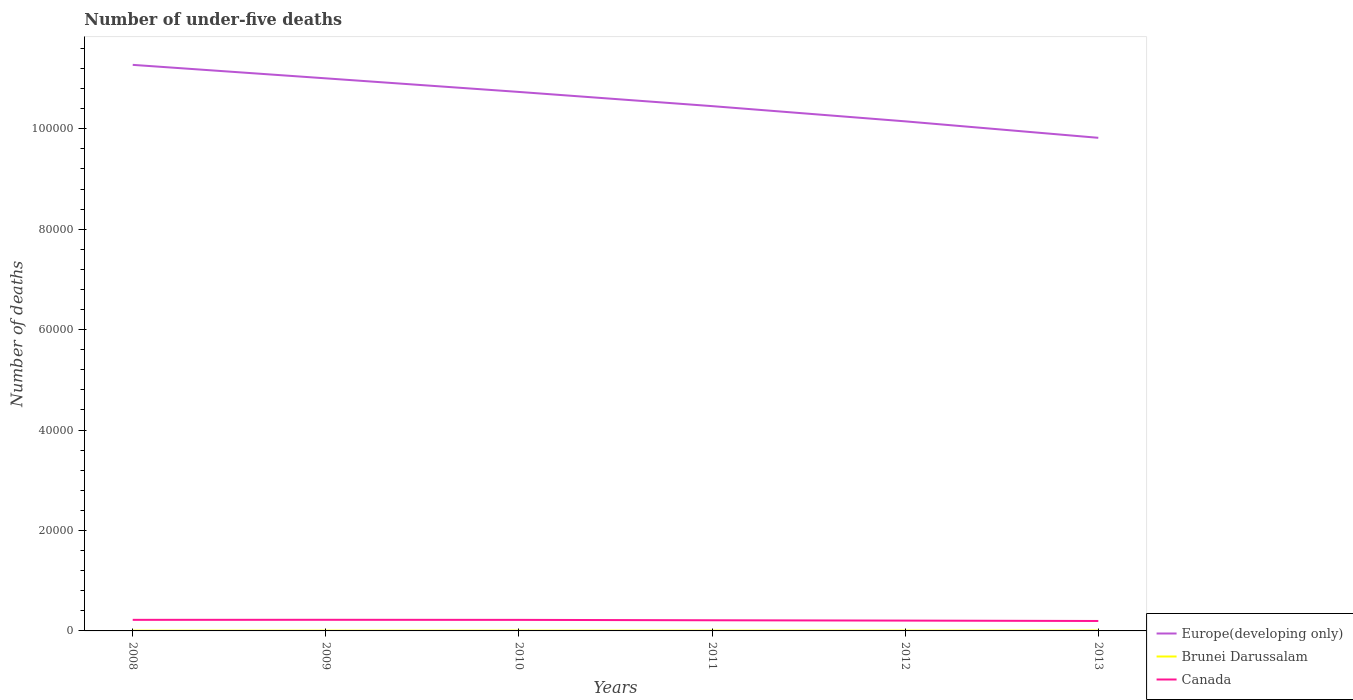How many different coloured lines are there?
Offer a very short reply. 3. Does the line corresponding to Europe(developing only) intersect with the line corresponding to Canada?
Provide a short and direct response. No. Across all years, what is the maximum number of under-five deaths in Canada?
Provide a short and direct response. 1978. What is the total number of under-five deaths in Brunei Darussalam in the graph?
Provide a short and direct response. -14. What is the difference between the highest and the second highest number of under-five deaths in Canada?
Your answer should be very brief. 239. What is the difference between the highest and the lowest number of under-five deaths in Canada?
Your answer should be compact. 3. Does the graph contain grids?
Keep it short and to the point. No. Where does the legend appear in the graph?
Provide a short and direct response. Bottom right. How are the legend labels stacked?
Your response must be concise. Vertical. What is the title of the graph?
Offer a terse response. Number of under-five deaths. What is the label or title of the Y-axis?
Offer a very short reply. Number of deaths. What is the Number of deaths in Europe(developing only) in 2008?
Your response must be concise. 1.13e+05. What is the Number of deaths in Brunei Darussalam in 2008?
Provide a short and direct response. 53. What is the Number of deaths of Canada in 2008?
Provide a succinct answer. 2206. What is the Number of deaths of Europe(developing only) in 2009?
Provide a succinct answer. 1.10e+05. What is the Number of deaths in Brunei Darussalam in 2009?
Your answer should be very brief. 53. What is the Number of deaths in Canada in 2009?
Keep it short and to the point. 2217. What is the Number of deaths in Europe(developing only) in 2010?
Ensure brevity in your answer.  1.07e+05. What is the Number of deaths of Canada in 2010?
Ensure brevity in your answer.  2201. What is the Number of deaths of Europe(developing only) in 2011?
Offer a very short reply. 1.05e+05. What is the Number of deaths in Canada in 2011?
Provide a short and direct response. 2121. What is the Number of deaths of Europe(developing only) in 2012?
Keep it short and to the point. 1.01e+05. What is the Number of deaths of Canada in 2012?
Ensure brevity in your answer.  2056. What is the Number of deaths in Europe(developing only) in 2013?
Your answer should be compact. 9.82e+04. What is the Number of deaths in Brunei Darussalam in 2013?
Offer a very short reply. 69. What is the Number of deaths in Canada in 2013?
Your response must be concise. 1978. Across all years, what is the maximum Number of deaths in Europe(developing only)?
Give a very brief answer. 1.13e+05. Across all years, what is the maximum Number of deaths in Brunei Darussalam?
Keep it short and to the point. 69. Across all years, what is the maximum Number of deaths of Canada?
Offer a terse response. 2217. Across all years, what is the minimum Number of deaths of Europe(developing only)?
Provide a short and direct response. 9.82e+04. Across all years, what is the minimum Number of deaths of Brunei Darussalam?
Offer a terse response. 53. Across all years, what is the minimum Number of deaths in Canada?
Provide a short and direct response. 1978. What is the total Number of deaths in Europe(developing only) in the graph?
Ensure brevity in your answer.  6.34e+05. What is the total Number of deaths of Brunei Darussalam in the graph?
Offer a very short reply. 351. What is the total Number of deaths of Canada in the graph?
Offer a terse response. 1.28e+04. What is the difference between the Number of deaths in Europe(developing only) in 2008 and that in 2009?
Offer a very short reply. 2685. What is the difference between the Number of deaths of Canada in 2008 and that in 2009?
Make the answer very short. -11. What is the difference between the Number of deaths in Europe(developing only) in 2008 and that in 2010?
Make the answer very short. 5391. What is the difference between the Number of deaths in Brunei Darussalam in 2008 and that in 2010?
Provide a short and direct response. -2. What is the difference between the Number of deaths in Europe(developing only) in 2008 and that in 2011?
Give a very brief answer. 8218. What is the difference between the Number of deaths of Brunei Darussalam in 2008 and that in 2011?
Provide a succinct answer. -5. What is the difference between the Number of deaths of Europe(developing only) in 2008 and that in 2012?
Provide a succinct answer. 1.12e+04. What is the difference between the Number of deaths of Canada in 2008 and that in 2012?
Your answer should be very brief. 150. What is the difference between the Number of deaths of Europe(developing only) in 2008 and that in 2013?
Your response must be concise. 1.45e+04. What is the difference between the Number of deaths in Canada in 2008 and that in 2013?
Offer a terse response. 228. What is the difference between the Number of deaths in Europe(developing only) in 2009 and that in 2010?
Your response must be concise. 2706. What is the difference between the Number of deaths in Brunei Darussalam in 2009 and that in 2010?
Your answer should be very brief. -2. What is the difference between the Number of deaths of Europe(developing only) in 2009 and that in 2011?
Make the answer very short. 5533. What is the difference between the Number of deaths of Brunei Darussalam in 2009 and that in 2011?
Keep it short and to the point. -5. What is the difference between the Number of deaths of Canada in 2009 and that in 2011?
Provide a succinct answer. 96. What is the difference between the Number of deaths in Europe(developing only) in 2009 and that in 2012?
Give a very brief answer. 8563. What is the difference between the Number of deaths in Canada in 2009 and that in 2012?
Your answer should be compact. 161. What is the difference between the Number of deaths in Europe(developing only) in 2009 and that in 2013?
Ensure brevity in your answer.  1.18e+04. What is the difference between the Number of deaths of Canada in 2009 and that in 2013?
Make the answer very short. 239. What is the difference between the Number of deaths in Europe(developing only) in 2010 and that in 2011?
Offer a terse response. 2827. What is the difference between the Number of deaths in Canada in 2010 and that in 2011?
Give a very brief answer. 80. What is the difference between the Number of deaths of Europe(developing only) in 2010 and that in 2012?
Provide a short and direct response. 5857. What is the difference between the Number of deaths of Canada in 2010 and that in 2012?
Your answer should be compact. 145. What is the difference between the Number of deaths in Europe(developing only) in 2010 and that in 2013?
Your answer should be compact. 9137. What is the difference between the Number of deaths in Canada in 2010 and that in 2013?
Provide a succinct answer. 223. What is the difference between the Number of deaths in Europe(developing only) in 2011 and that in 2012?
Ensure brevity in your answer.  3030. What is the difference between the Number of deaths in Brunei Darussalam in 2011 and that in 2012?
Ensure brevity in your answer.  -5. What is the difference between the Number of deaths of Europe(developing only) in 2011 and that in 2013?
Give a very brief answer. 6310. What is the difference between the Number of deaths of Canada in 2011 and that in 2013?
Provide a short and direct response. 143. What is the difference between the Number of deaths of Europe(developing only) in 2012 and that in 2013?
Make the answer very short. 3280. What is the difference between the Number of deaths in Canada in 2012 and that in 2013?
Your response must be concise. 78. What is the difference between the Number of deaths of Europe(developing only) in 2008 and the Number of deaths of Brunei Darussalam in 2009?
Your answer should be compact. 1.13e+05. What is the difference between the Number of deaths in Europe(developing only) in 2008 and the Number of deaths in Canada in 2009?
Your answer should be compact. 1.11e+05. What is the difference between the Number of deaths in Brunei Darussalam in 2008 and the Number of deaths in Canada in 2009?
Ensure brevity in your answer.  -2164. What is the difference between the Number of deaths of Europe(developing only) in 2008 and the Number of deaths of Brunei Darussalam in 2010?
Provide a short and direct response. 1.13e+05. What is the difference between the Number of deaths in Europe(developing only) in 2008 and the Number of deaths in Canada in 2010?
Make the answer very short. 1.11e+05. What is the difference between the Number of deaths in Brunei Darussalam in 2008 and the Number of deaths in Canada in 2010?
Your answer should be very brief. -2148. What is the difference between the Number of deaths of Europe(developing only) in 2008 and the Number of deaths of Brunei Darussalam in 2011?
Keep it short and to the point. 1.13e+05. What is the difference between the Number of deaths in Europe(developing only) in 2008 and the Number of deaths in Canada in 2011?
Offer a terse response. 1.11e+05. What is the difference between the Number of deaths of Brunei Darussalam in 2008 and the Number of deaths of Canada in 2011?
Make the answer very short. -2068. What is the difference between the Number of deaths in Europe(developing only) in 2008 and the Number of deaths in Brunei Darussalam in 2012?
Keep it short and to the point. 1.13e+05. What is the difference between the Number of deaths in Europe(developing only) in 2008 and the Number of deaths in Canada in 2012?
Your answer should be very brief. 1.11e+05. What is the difference between the Number of deaths of Brunei Darussalam in 2008 and the Number of deaths of Canada in 2012?
Ensure brevity in your answer.  -2003. What is the difference between the Number of deaths of Europe(developing only) in 2008 and the Number of deaths of Brunei Darussalam in 2013?
Keep it short and to the point. 1.13e+05. What is the difference between the Number of deaths in Europe(developing only) in 2008 and the Number of deaths in Canada in 2013?
Provide a succinct answer. 1.11e+05. What is the difference between the Number of deaths in Brunei Darussalam in 2008 and the Number of deaths in Canada in 2013?
Your response must be concise. -1925. What is the difference between the Number of deaths of Europe(developing only) in 2009 and the Number of deaths of Brunei Darussalam in 2010?
Make the answer very short. 1.10e+05. What is the difference between the Number of deaths of Europe(developing only) in 2009 and the Number of deaths of Canada in 2010?
Ensure brevity in your answer.  1.08e+05. What is the difference between the Number of deaths in Brunei Darussalam in 2009 and the Number of deaths in Canada in 2010?
Provide a short and direct response. -2148. What is the difference between the Number of deaths in Europe(developing only) in 2009 and the Number of deaths in Brunei Darussalam in 2011?
Provide a short and direct response. 1.10e+05. What is the difference between the Number of deaths of Europe(developing only) in 2009 and the Number of deaths of Canada in 2011?
Provide a succinct answer. 1.08e+05. What is the difference between the Number of deaths of Brunei Darussalam in 2009 and the Number of deaths of Canada in 2011?
Your answer should be compact. -2068. What is the difference between the Number of deaths in Europe(developing only) in 2009 and the Number of deaths in Brunei Darussalam in 2012?
Your answer should be compact. 1.10e+05. What is the difference between the Number of deaths in Europe(developing only) in 2009 and the Number of deaths in Canada in 2012?
Your response must be concise. 1.08e+05. What is the difference between the Number of deaths of Brunei Darussalam in 2009 and the Number of deaths of Canada in 2012?
Offer a terse response. -2003. What is the difference between the Number of deaths in Europe(developing only) in 2009 and the Number of deaths in Brunei Darussalam in 2013?
Ensure brevity in your answer.  1.10e+05. What is the difference between the Number of deaths of Europe(developing only) in 2009 and the Number of deaths of Canada in 2013?
Offer a terse response. 1.08e+05. What is the difference between the Number of deaths in Brunei Darussalam in 2009 and the Number of deaths in Canada in 2013?
Your response must be concise. -1925. What is the difference between the Number of deaths of Europe(developing only) in 2010 and the Number of deaths of Brunei Darussalam in 2011?
Keep it short and to the point. 1.07e+05. What is the difference between the Number of deaths of Europe(developing only) in 2010 and the Number of deaths of Canada in 2011?
Provide a succinct answer. 1.05e+05. What is the difference between the Number of deaths of Brunei Darussalam in 2010 and the Number of deaths of Canada in 2011?
Offer a terse response. -2066. What is the difference between the Number of deaths in Europe(developing only) in 2010 and the Number of deaths in Brunei Darussalam in 2012?
Provide a short and direct response. 1.07e+05. What is the difference between the Number of deaths of Europe(developing only) in 2010 and the Number of deaths of Canada in 2012?
Keep it short and to the point. 1.05e+05. What is the difference between the Number of deaths of Brunei Darussalam in 2010 and the Number of deaths of Canada in 2012?
Provide a short and direct response. -2001. What is the difference between the Number of deaths of Europe(developing only) in 2010 and the Number of deaths of Brunei Darussalam in 2013?
Your answer should be compact. 1.07e+05. What is the difference between the Number of deaths in Europe(developing only) in 2010 and the Number of deaths in Canada in 2013?
Keep it short and to the point. 1.05e+05. What is the difference between the Number of deaths in Brunei Darussalam in 2010 and the Number of deaths in Canada in 2013?
Offer a terse response. -1923. What is the difference between the Number of deaths in Europe(developing only) in 2011 and the Number of deaths in Brunei Darussalam in 2012?
Ensure brevity in your answer.  1.04e+05. What is the difference between the Number of deaths in Europe(developing only) in 2011 and the Number of deaths in Canada in 2012?
Provide a succinct answer. 1.02e+05. What is the difference between the Number of deaths in Brunei Darussalam in 2011 and the Number of deaths in Canada in 2012?
Make the answer very short. -1998. What is the difference between the Number of deaths in Europe(developing only) in 2011 and the Number of deaths in Brunei Darussalam in 2013?
Your answer should be compact. 1.04e+05. What is the difference between the Number of deaths of Europe(developing only) in 2011 and the Number of deaths of Canada in 2013?
Make the answer very short. 1.03e+05. What is the difference between the Number of deaths of Brunei Darussalam in 2011 and the Number of deaths of Canada in 2013?
Your answer should be compact. -1920. What is the difference between the Number of deaths in Europe(developing only) in 2012 and the Number of deaths in Brunei Darussalam in 2013?
Your response must be concise. 1.01e+05. What is the difference between the Number of deaths of Europe(developing only) in 2012 and the Number of deaths of Canada in 2013?
Provide a short and direct response. 9.95e+04. What is the difference between the Number of deaths of Brunei Darussalam in 2012 and the Number of deaths of Canada in 2013?
Your answer should be very brief. -1915. What is the average Number of deaths of Europe(developing only) per year?
Keep it short and to the point. 1.06e+05. What is the average Number of deaths in Brunei Darussalam per year?
Ensure brevity in your answer.  58.5. What is the average Number of deaths in Canada per year?
Give a very brief answer. 2129.83. In the year 2008, what is the difference between the Number of deaths of Europe(developing only) and Number of deaths of Brunei Darussalam?
Your answer should be very brief. 1.13e+05. In the year 2008, what is the difference between the Number of deaths of Europe(developing only) and Number of deaths of Canada?
Provide a succinct answer. 1.11e+05. In the year 2008, what is the difference between the Number of deaths of Brunei Darussalam and Number of deaths of Canada?
Provide a short and direct response. -2153. In the year 2009, what is the difference between the Number of deaths in Europe(developing only) and Number of deaths in Brunei Darussalam?
Provide a succinct answer. 1.10e+05. In the year 2009, what is the difference between the Number of deaths of Europe(developing only) and Number of deaths of Canada?
Give a very brief answer. 1.08e+05. In the year 2009, what is the difference between the Number of deaths of Brunei Darussalam and Number of deaths of Canada?
Your answer should be compact. -2164. In the year 2010, what is the difference between the Number of deaths of Europe(developing only) and Number of deaths of Brunei Darussalam?
Provide a short and direct response. 1.07e+05. In the year 2010, what is the difference between the Number of deaths in Europe(developing only) and Number of deaths in Canada?
Your answer should be very brief. 1.05e+05. In the year 2010, what is the difference between the Number of deaths of Brunei Darussalam and Number of deaths of Canada?
Keep it short and to the point. -2146. In the year 2011, what is the difference between the Number of deaths of Europe(developing only) and Number of deaths of Brunei Darussalam?
Your answer should be very brief. 1.04e+05. In the year 2011, what is the difference between the Number of deaths of Europe(developing only) and Number of deaths of Canada?
Make the answer very short. 1.02e+05. In the year 2011, what is the difference between the Number of deaths of Brunei Darussalam and Number of deaths of Canada?
Make the answer very short. -2063. In the year 2012, what is the difference between the Number of deaths of Europe(developing only) and Number of deaths of Brunei Darussalam?
Offer a very short reply. 1.01e+05. In the year 2012, what is the difference between the Number of deaths in Europe(developing only) and Number of deaths in Canada?
Provide a succinct answer. 9.94e+04. In the year 2012, what is the difference between the Number of deaths of Brunei Darussalam and Number of deaths of Canada?
Provide a short and direct response. -1993. In the year 2013, what is the difference between the Number of deaths of Europe(developing only) and Number of deaths of Brunei Darussalam?
Your answer should be very brief. 9.81e+04. In the year 2013, what is the difference between the Number of deaths of Europe(developing only) and Number of deaths of Canada?
Offer a terse response. 9.62e+04. In the year 2013, what is the difference between the Number of deaths in Brunei Darussalam and Number of deaths in Canada?
Offer a very short reply. -1909. What is the ratio of the Number of deaths in Europe(developing only) in 2008 to that in 2009?
Keep it short and to the point. 1.02. What is the ratio of the Number of deaths of Canada in 2008 to that in 2009?
Ensure brevity in your answer.  0.99. What is the ratio of the Number of deaths of Europe(developing only) in 2008 to that in 2010?
Give a very brief answer. 1.05. What is the ratio of the Number of deaths in Brunei Darussalam in 2008 to that in 2010?
Offer a very short reply. 0.96. What is the ratio of the Number of deaths in Canada in 2008 to that in 2010?
Your answer should be compact. 1. What is the ratio of the Number of deaths of Europe(developing only) in 2008 to that in 2011?
Provide a succinct answer. 1.08. What is the ratio of the Number of deaths in Brunei Darussalam in 2008 to that in 2011?
Keep it short and to the point. 0.91. What is the ratio of the Number of deaths of Canada in 2008 to that in 2011?
Keep it short and to the point. 1.04. What is the ratio of the Number of deaths of Europe(developing only) in 2008 to that in 2012?
Offer a very short reply. 1.11. What is the ratio of the Number of deaths of Brunei Darussalam in 2008 to that in 2012?
Provide a short and direct response. 0.84. What is the ratio of the Number of deaths of Canada in 2008 to that in 2012?
Your answer should be very brief. 1.07. What is the ratio of the Number of deaths in Europe(developing only) in 2008 to that in 2013?
Your answer should be very brief. 1.15. What is the ratio of the Number of deaths in Brunei Darussalam in 2008 to that in 2013?
Provide a short and direct response. 0.77. What is the ratio of the Number of deaths of Canada in 2008 to that in 2013?
Provide a succinct answer. 1.12. What is the ratio of the Number of deaths of Europe(developing only) in 2009 to that in 2010?
Offer a terse response. 1.03. What is the ratio of the Number of deaths in Brunei Darussalam in 2009 to that in 2010?
Keep it short and to the point. 0.96. What is the ratio of the Number of deaths in Canada in 2009 to that in 2010?
Provide a short and direct response. 1.01. What is the ratio of the Number of deaths in Europe(developing only) in 2009 to that in 2011?
Make the answer very short. 1.05. What is the ratio of the Number of deaths of Brunei Darussalam in 2009 to that in 2011?
Keep it short and to the point. 0.91. What is the ratio of the Number of deaths in Canada in 2009 to that in 2011?
Offer a terse response. 1.05. What is the ratio of the Number of deaths in Europe(developing only) in 2009 to that in 2012?
Your response must be concise. 1.08. What is the ratio of the Number of deaths in Brunei Darussalam in 2009 to that in 2012?
Your response must be concise. 0.84. What is the ratio of the Number of deaths in Canada in 2009 to that in 2012?
Provide a succinct answer. 1.08. What is the ratio of the Number of deaths of Europe(developing only) in 2009 to that in 2013?
Your answer should be very brief. 1.12. What is the ratio of the Number of deaths of Brunei Darussalam in 2009 to that in 2013?
Your answer should be compact. 0.77. What is the ratio of the Number of deaths of Canada in 2009 to that in 2013?
Your answer should be very brief. 1.12. What is the ratio of the Number of deaths of Europe(developing only) in 2010 to that in 2011?
Your answer should be compact. 1.03. What is the ratio of the Number of deaths of Brunei Darussalam in 2010 to that in 2011?
Your answer should be compact. 0.95. What is the ratio of the Number of deaths of Canada in 2010 to that in 2011?
Your answer should be compact. 1.04. What is the ratio of the Number of deaths of Europe(developing only) in 2010 to that in 2012?
Provide a succinct answer. 1.06. What is the ratio of the Number of deaths of Brunei Darussalam in 2010 to that in 2012?
Provide a succinct answer. 0.87. What is the ratio of the Number of deaths in Canada in 2010 to that in 2012?
Offer a terse response. 1.07. What is the ratio of the Number of deaths of Europe(developing only) in 2010 to that in 2013?
Give a very brief answer. 1.09. What is the ratio of the Number of deaths in Brunei Darussalam in 2010 to that in 2013?
Your answer should be very brief. 0.8. What is the ratio of the Number of deaths in Canada in 2010 to that in 2013?
Ensure brevity in your answer.  1.11. What is the ratio of the Number of deaths of Europe(developing only) in 2011 to that in 2012?
Keep it short and to the point. 1.03. What is the ratio of the Number of deaths in Brunei Darussalam in 2011 to that in 2012?
Provide a succinct answer. 0.92. What is the ratio of the Number of deaths of Canada in 2011 to that in 2012?
Your answer should be compact. 1.03. What is the ratio of the Number of deaths in Europe(developing only) in 2011 to that in 2013?
Give a very brief answer. 1.06. What is the ratio of the Number of deaths in Brunei Darussalam in 2011 to that in 2013?
Provide a short and direct response. 0.84. What is the ratio of the Number of deaths of Canada in 2011 to that in 2013?
Offer a very short reply. 1.07. What is the ratio of the Number of deaths of Europe(developing only) in 2012 to that in 2013?
Your response must be concise. 1.03. What is the ratio of the Number of deaths of Brunei Darussalam in 2012 to that in 2013?
Make the answer very short. 0.91. What is the ratio of the Number of deaths in Canada in 2012 to that in 2013?
Your response must be concise. 1.04. What is the difference between the highest and the second highest Number of deaths in Europe(developing only)?
Provide a short and direct response. 2685. What is the difference between the highest and the second highest Number of deaths in Brunei Darussalam?
Your response must be concise. 6. What is the difference between the highest and the second highest Number of deaths in Canada?
Provide a short and direct response. 11. What is the difference between the highest and the lowest Number of deaths in Europe(developing only)?
Give a very brief answer. 1.45e+04. What is the difference between the highest and the lowest Number of deaths in Canada?
Ensure brevity in your answer.  239. 